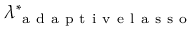Convert formula to latex. <formula><loc_0><loc_0><loc_500><loc_500>\lambda _ { a d a p t i v e l a s s o } ^ { \ast }</formula> 